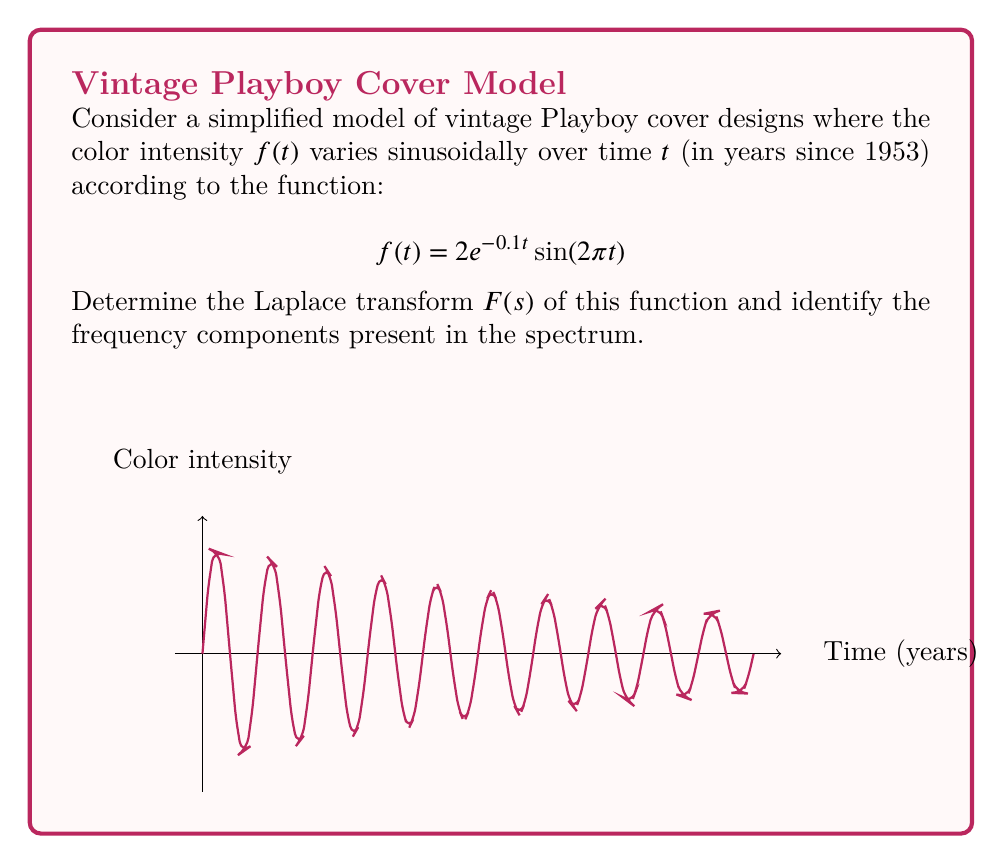Can you answer this question? To solve this problem, we'll follow these steps:

1) The Laplace transform of $f(t) = 2e^{-0.1t}\sin(2\pi t)$ is given by:

   $$F(s) = \mathcal{L}\{f(t)\} = \int_0^\infty 2e^{-0.1t}\sin(2\pi t)e^{-st}dt$$

2) We can use the Laplace transform property for damped sinusoidal functions:

   $$\mathcal{L}\{e^{-at}\sin(\omega t)\} = \frac{\omega}{(s+a)^2 + \omega^2}$$

3) In our case, $a = 0.1$, $\omega = 2\pi$, and there's a factor of 2:

   $$F(s) = 2 \cdot \frac{2\pi}{(s+0.1)^2 + (2\pi)^2}$$

4) Simplifying:

   $$F(s) = \frac{4\pi}{(s+0.1)^2 + 4\pi^2}$$

5) To identify the frequency components, we look at the poles of $F(s)$:

   $$(s+0.1)^2 + 4\pi^2 = 0$$
   $$(s+0.1)^2 = -4\pi^2$$
   $$s+0.1 = \pm 2\pi i$$
   $$s = -0.1 \pm 2\pi i$$

6) The imaginary parts of the poles give us the frequency components:

   $$\omega = \pm 2\pi \text{ rad/year}$$

   This corresponds to a frequency of 1 cycle per year.
Answer: $F(s) = \frac{4\pi}{(s+0.1)^2 + 4\pi^2}$; Frequency: 1 cycle/year 